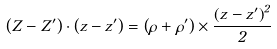Convert formula to latex. <formula><loc_0><loc_0><loc_500><loc_500>\left ( Z - Z ^ { \prime } \right ) \cdot \left ( z - z ^ { \prime } \right ) = \left ( \rho + \rho ^ { \prime } \right ) \times \frac { \left ( z - z ^ { \prime } \right ) ^ { 2 } } { 2 }</formula> 